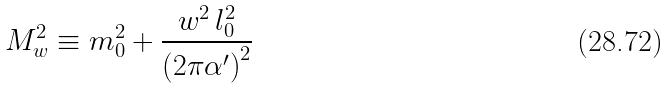<formula> <loc_0><loc_0><loc_500><loc_500>M ^ { 2 } _ { w } \equiv m _ { 0 } ^ { 2 } + \frac { w ^ { 2 } \, l _ { 0 } ^ { 2 } } { \left ( 2 \pi \alpha ^ { \prime } \right ) ^ { 2 } }</formula> 